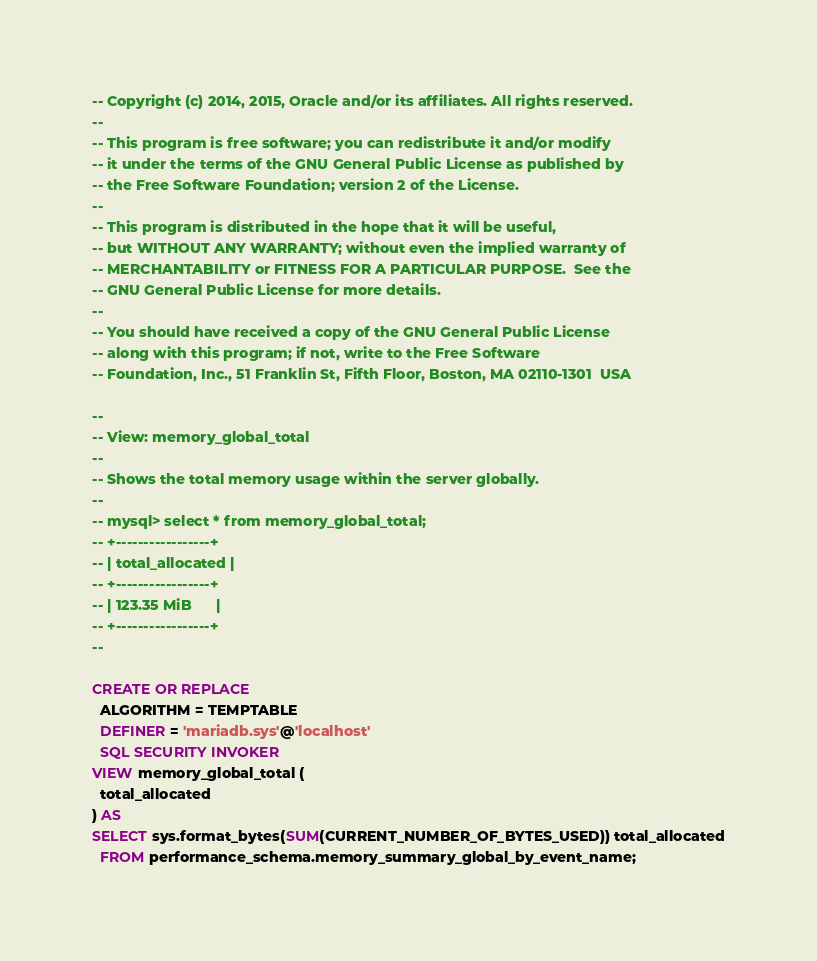<code> <loc_0><loc_0><loc_500><loc_500><_SQL_>-- Copyright (c) 2014, 2015, Oracle and/or its affiliates. All rights reserved.
--
-- This program is free software; you can redistribute it and/or modify
-- it under the terms of the GNU General Public License as published by
-- the Free Software Foundation; version 2 of the License.
--
-- This program is distributed in the hope that it will be useful,
-- but WITHOUT ANY WARRANTY; without even the implied warranty of
-- MERCHANTABILITY or FITNESS FOR A PARTICULAR PURPOSE.  See the
-- GNU General Public License for more details.
--
-- You should have received a copy of the GNU General Public License
-- along with this program; if not, write to the Free Software
-- Foundation, Inc., 51 Franklin St, Fifth Floor, Boston, MA 02110-1301  USA

--
-- View: memory_global_total
-- 
-- Shows the total memory usage within the server globally.
--
-- mysql> select * from memory_global_total;
-- +-----------------+
-- | total_allocated |
-- +-----------------+
-- | 123.35 MiB      |
-- +-----------------+
--

CREATE OR REPLACE
  ALGORITHM = TEMPTABLE
  DEFINER = 'mariadb.sys'@'localhost'
  SQL SECURITY INVOKER 
VIEW memory_global_total (
  total_allocated
) AS
SELECT sys.format_bytes(SUM(CURRENT_NUMBER_OF_BYTES_USED)) total_allocated
  FROM performance_schema.memory_summary_global_by_event_name;
</code> 